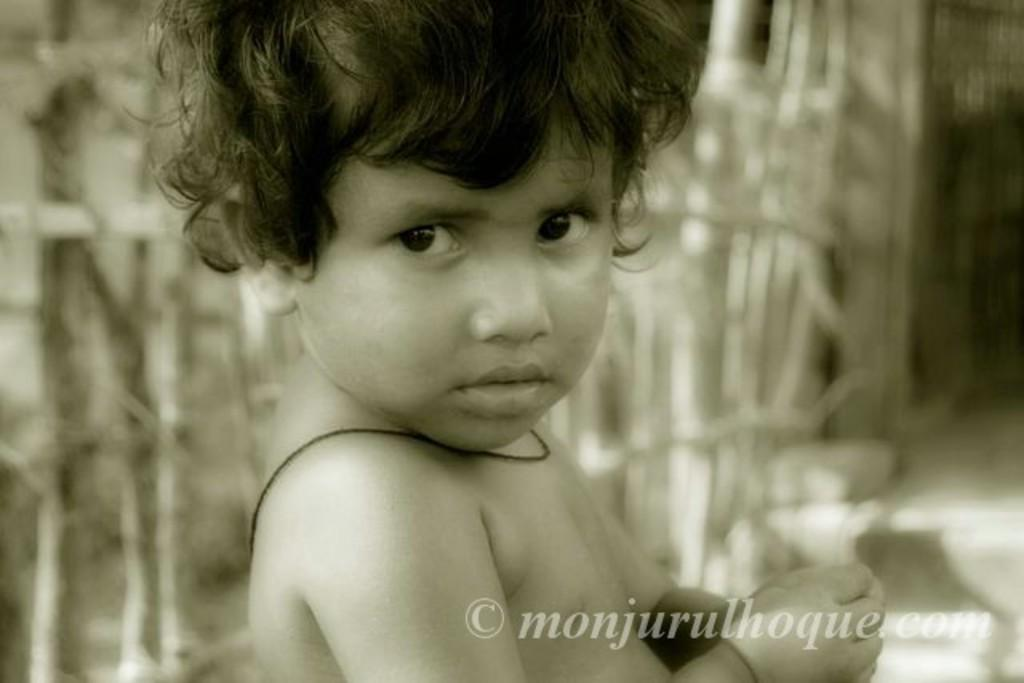What is the main subject of the image? There is a kid in the image. Can you describe the background of the image? The background of the image is blurred. Is there any additional information or markings in the image? Yes, there is a watermark in the bottom right corner of the image. What type of cloud can be seen in the image? There is no cloud present in the image. Is there a carriage visible in the image? There is no carriage present in the image. 